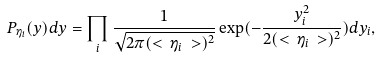<formula> <loc_0><loc_0><loc_500><loc_500>P _ { \eta _ { i } } ( y ) d y = \prod _ { i } \frac { 1 } { \sqrt { 2 \pi ( < \, \eta _ { i } \, > ) ^ { 2 } } } \exp ( - \frac { y _ { i } ^ { 2 } } { 2 ( < \, \eta _ { i } \, > ) ^ { 2 } } ) d y _ { i } ,</formula> 